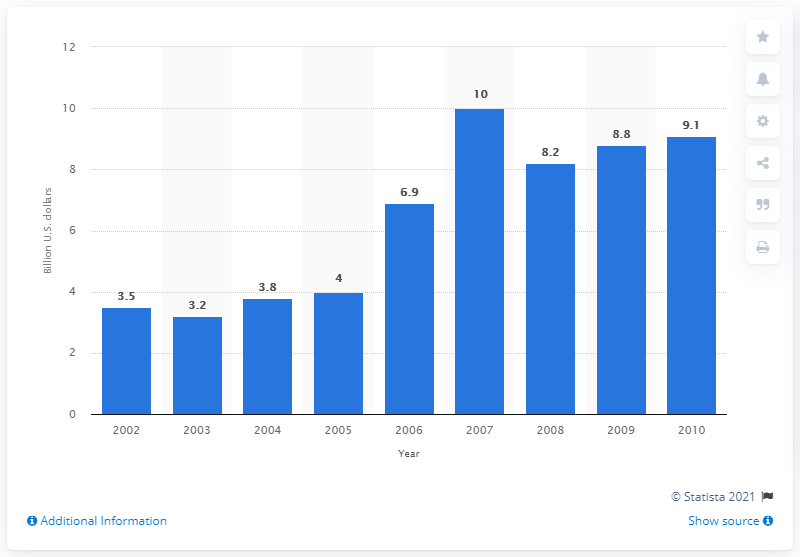Identify some key points in this picture. In 2009, the value of U.S. product shipments of household detergents was 8.8 billion dollars. 